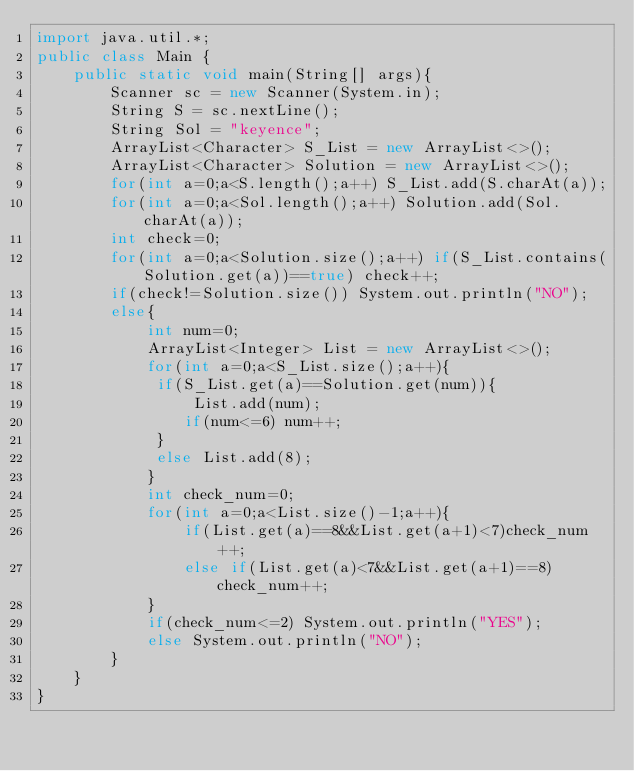<code> <loc_0><loc_0><loc_500><loc_500><_Java_>import java.util.*;
public class Main {
    public static void main(String[] args){
        Scanner sc = new Scanner(System.in);
        String S = sc.nextLine();
        String Sol = "keyence";
        ArrayList<Character> S_List = new ArrayList<>();
        ArrayList<Character> Solution = new ArrayList<>();
        for(int a=0;a<S.length();a++) S_List.add(S.charAt(a));
        for(int a=0;a<Sol.length();a++) Solution.add(Sol.charAt(a));
        int check=0;
        for(int a=0;a<Solution.size();a++) if(S_List.contains(Solution.get(a))==true) check++;
        if(check!=Solution.size()) System.out.println("NO");
        else{
            int num=0;
            ArrayList<Integer> List = new ArrayList<>();
            for(int a=0;a<S_List.size();a++){
             if(S_List.get(a)==Solution.get(num)){
                 List.add(num);
                if(num<=6) num++;
             }
             else List.add(8);
            }
            int check_num=0;
            for(int a=0;a<List.size()-1;a++){
                if(List.get(a)==8&&List.get(a+1)<7)check_num++;
                else if(List.get(a)<7&&List.get(a+1)==8)check_num++;
            }
            if(check_num<=2) System.out.println("YES");
            else System.out.println("NO");
        }
    }
}</code> 